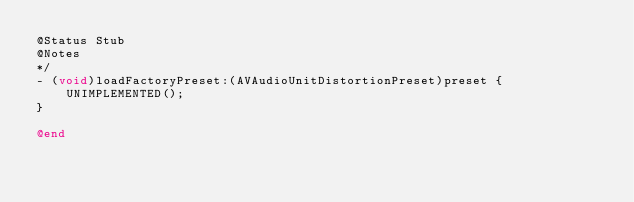Convert code to text. <code><loc_0><loc_0><loc_500><loc_500><_ObjectiveC_>@Status Stub
@Notes
*/
- (void)loadFactoryPreset:(AVAudioUnitDistortionPreset)preset {
    UNIMPLEMENTED();
}

@end
</code> 